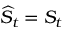<formula> <loc_0><loc_0><loc_500><loc_500>\widehat { S } _ { t } = S _ { t }</formula> 